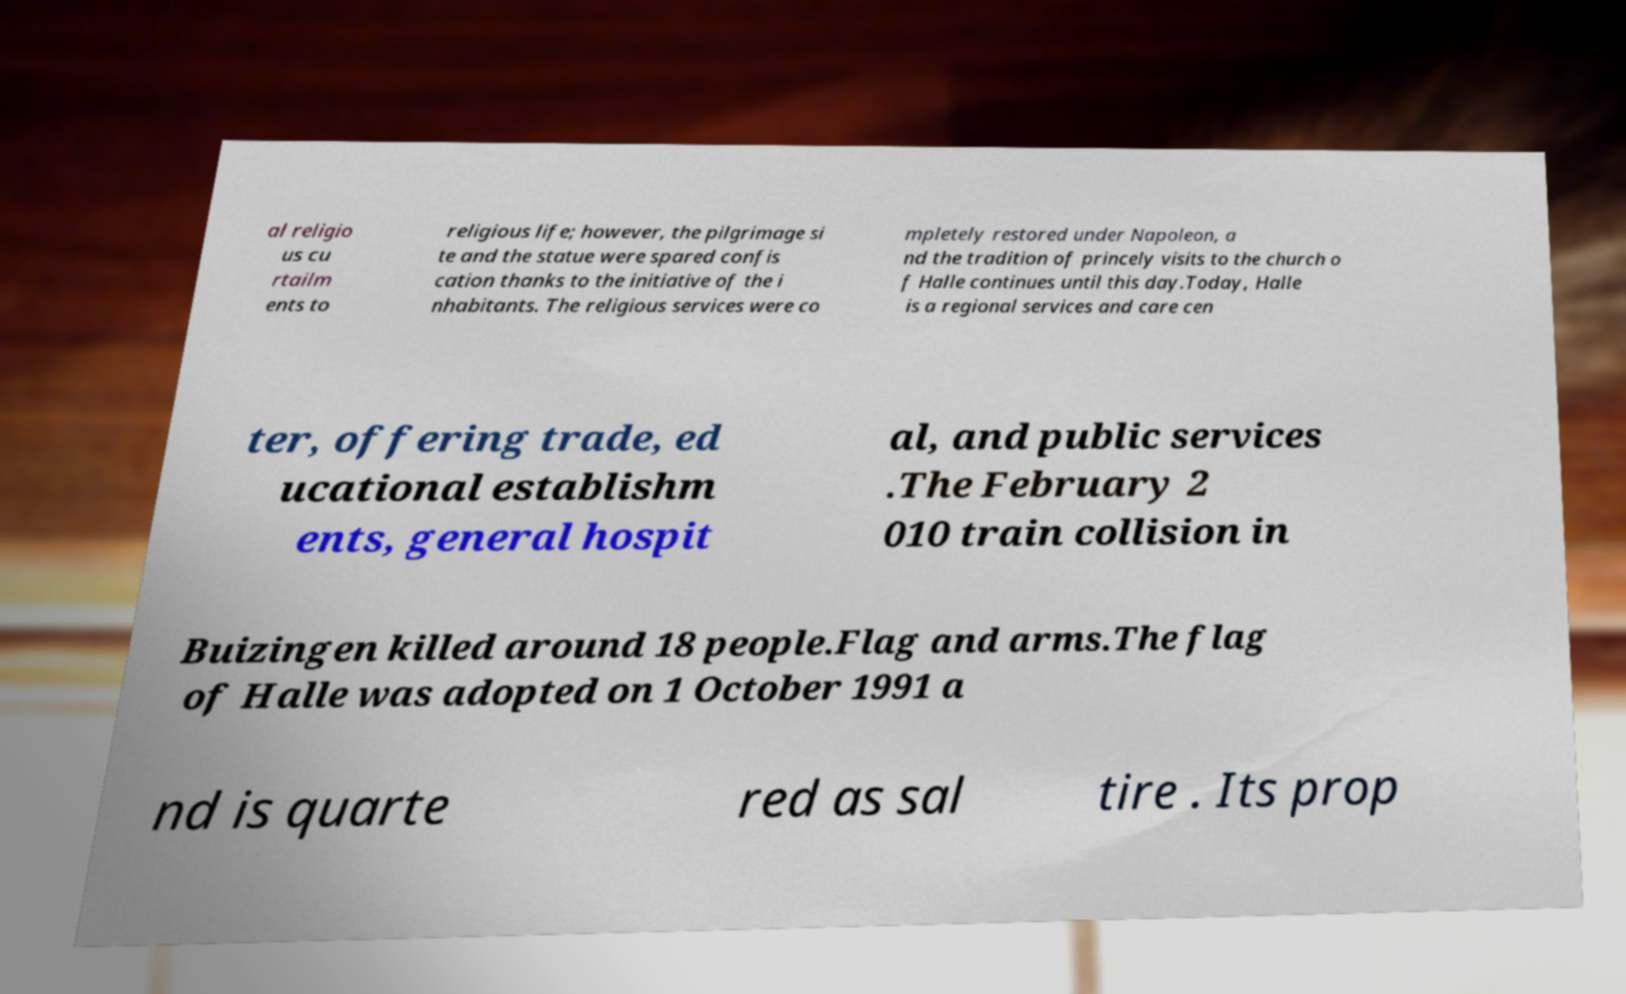Could you extract and type out the text from this image? al religio us cu rtailm ents to religious life; however, the pilgrimage si te and the statue were spared confis cation thanks to the initiative of the i nhabitants. The religious services were co mpletely restored under Napoleon, a nd the tradition of princely visits to the church o f Halle continues until this day.Today, Halle is a regional services and care cen ter, offering trade, ed ucational establishm ents, general hospit al, and public services .The February 2 010 train collision in Buizingen killed around 18 people.Flag and arms.The flag of Halle was adopted on 1 October 1991 a nd is quarte red as sal tire . Its prop 